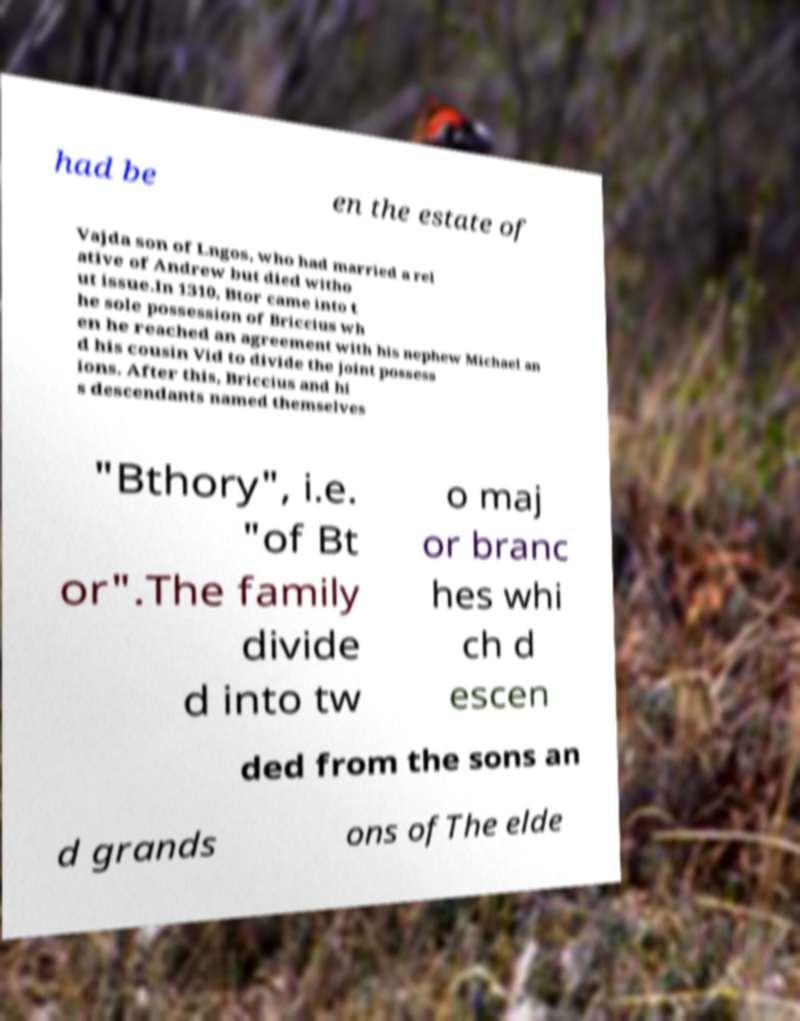What messages or text are displayed in this image? I need them in a readable, typed format. had be en the estate of Vajda son of Lngos, who had married a rel ative of Andrew but died witho ut issue.In 1310, Btor came into t he sole possession of Briccius wh en he reached an agreement with his nephew Michael an d his cousin Vid to divide the joint possess ions. After this, Briccius and hi s descendants named themselves "Bthory", i.e. "of Bt or".The family divide d into tw o maj or branc hes whi ch d escen ded from the sons an d grands ons ofThe elde 